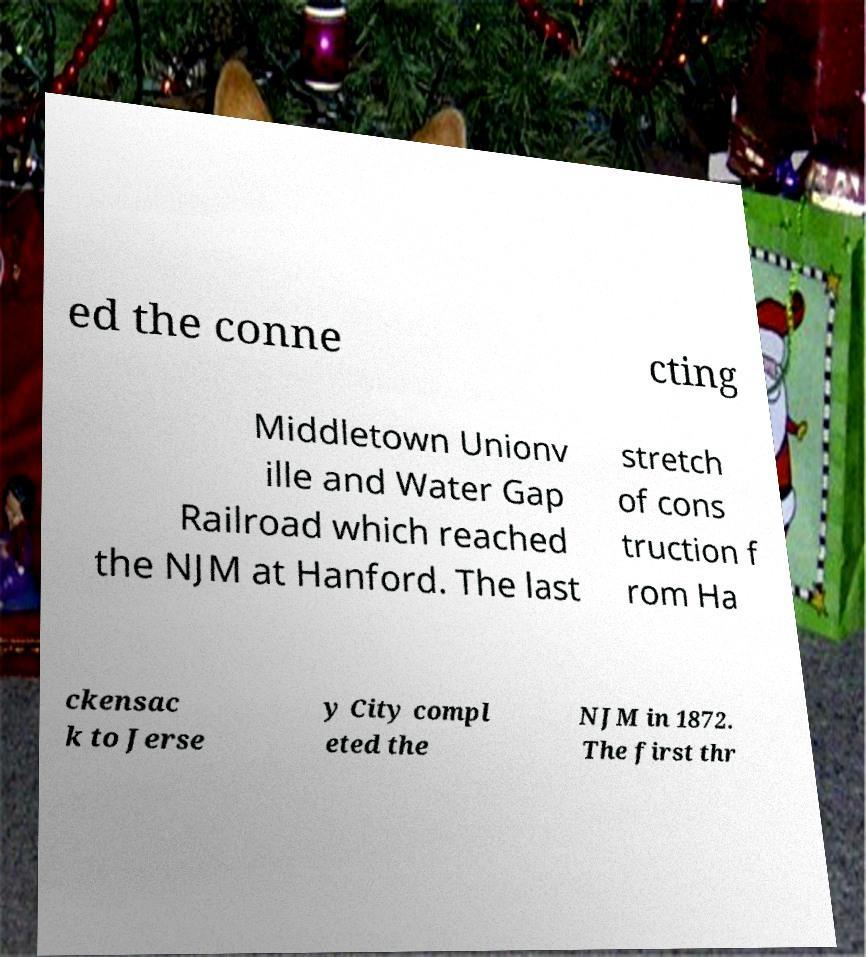For documentation purposes, I need the text within this image transcribed. Could you provide that? ed the conne cting Middletown Unionv ille and Water Gap Railroad which reached the NJM at Hanford. The last stretch of cons truction f rom Ha ckensac k to Jerse y City compl eted the NJM in 1872. The first thr 